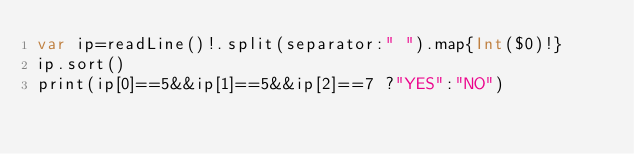Convert code to text. <code><loc_0><loc_0><loc_500><loc_500><_Swift_>var ip=readLine()!.split(separator:" ").map{Int($0)!}
ip.sort()
print(ip[0]==5&&ip[1]==5&&ip[2]==7 ?"YES":"NO")
</code> 